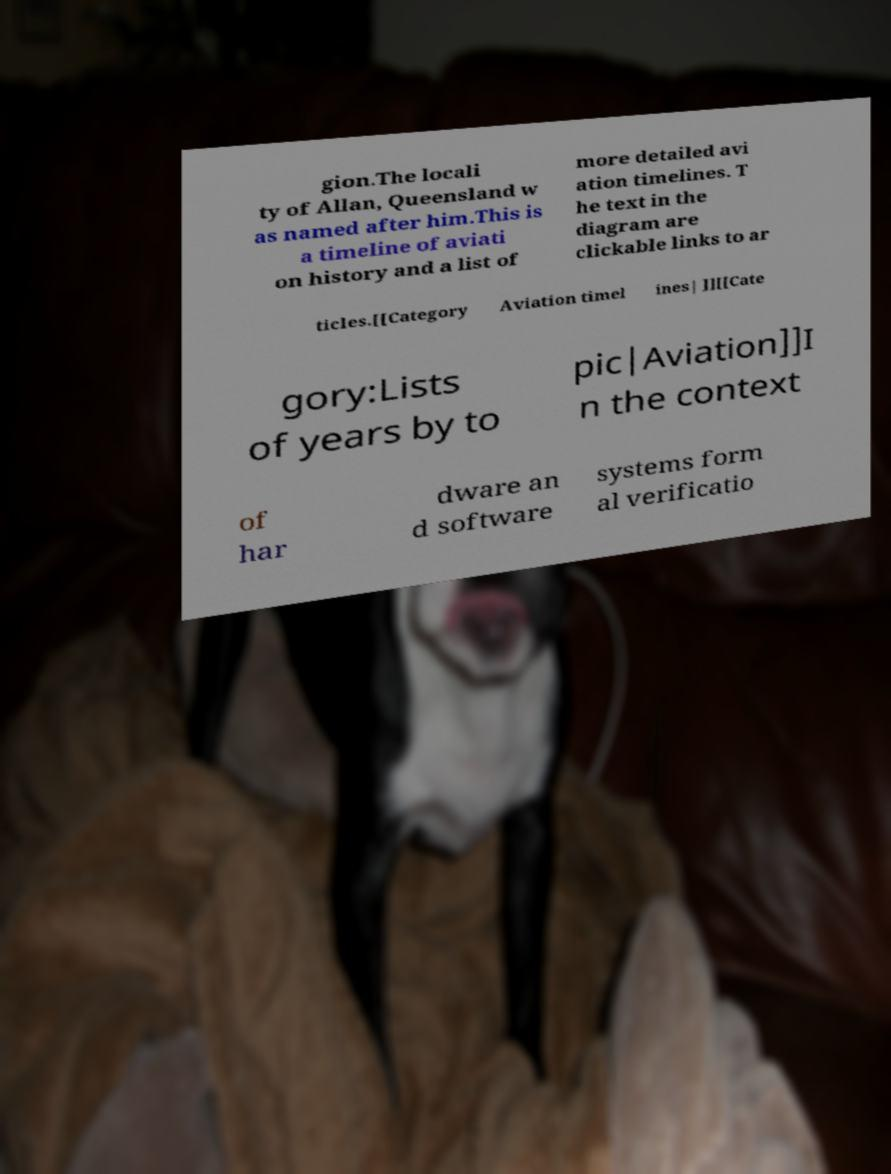Please read and relay the text visible in this image. What does it say? gion.The locali ty of Allan, Queensland w as named after him.This is a timeline of aviati on history and a list of more detailed avi ation timelines. T he text in the diagram are clickable links to ar ticles.[[Category Aviation timel ines| ]][[Cate gory:Lists of years by to pic|Aviation]]I n the context of har dware an d software systems form al verificatio 